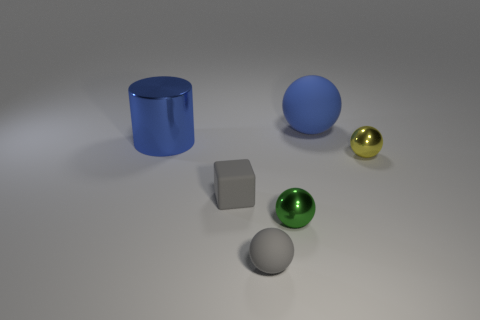Does the shiny cylinder have the same color as the rubber object that is behind the yellow metal ball?
Your answer should be compact. Yes. There is a rubber ball that is right of the tiny metallic object that is to the left of the tiny metallic object behind the small block; how big is it?
Make the answer very short. Large. How many small rubber things have the same color as the block?
Your response must be concise. 1. How many things are either small cyan shiny objects or shiny things on the left side of the big sphere?
Offer a terse response. 2. The big cylinder is what color?
Provide a succinct answer. Blue. There is a large thing on the left side of the large rubber thing; what is its color?
Your answer should be very brief. Blue. There is a tiny shiny sphere in front of the yellow object; what number of gray matte things are behind it?
Ensure brevity in your answer.  1. Is the size of the green object the same as the rubber sphere behind the small green shiny object?
Provide a short and direct response. No. Are there any other blue cylinders of the same size as the cylinder?
Provide a succinct answer. No. What number of objects are either large green cylinders or big blue things?
Your answer should be compact. 2. 